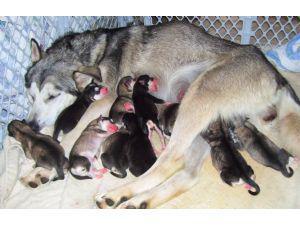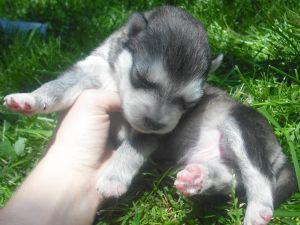The first image is the image on the left, the second image is the image on the right. Assess this claim about the two images: "The left and right image contains the same number of husky puppies.". Correct or not? Answer yes or no. No. The first image is the image on the left, the second image is the image on the right. For the images shown, is this caption "One image shows a reclining mother dog with her head on the left, nursing multiple puppies with their tails toward the camera." true? Answer yes or no. Yes. 